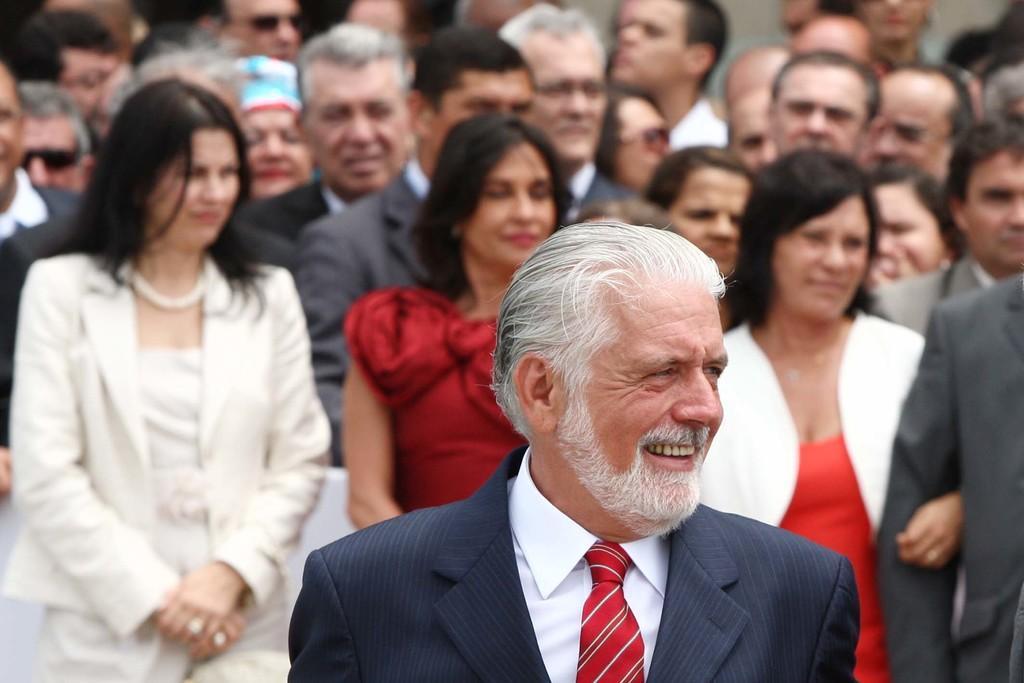How would you summarize this image in a sentence or two? In this image, we can see people and some are wearing coats and one of them is wearing a cap. 